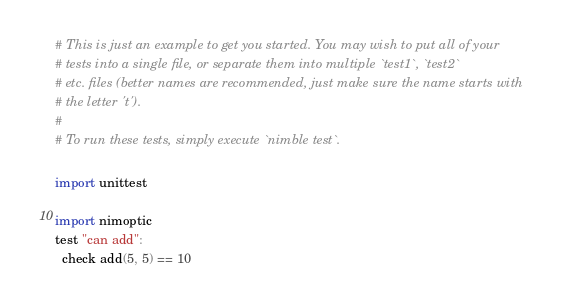Convert code to text. <code><loc_0><loc_0><loc_500><loc_500><_Nim_># This is just an example to get you started. You may wish to put all of your
# tests into a single file, or separate them into multiple `test1`, `test2`
# etc. files (better names are recommended, just make sure the name starts with
# the letter 't').
#
# To run these tests, simply execute `nimble test`.

import unittest

import nimoptic
test "can add":
  check add(5, 5) == 10
</code> 